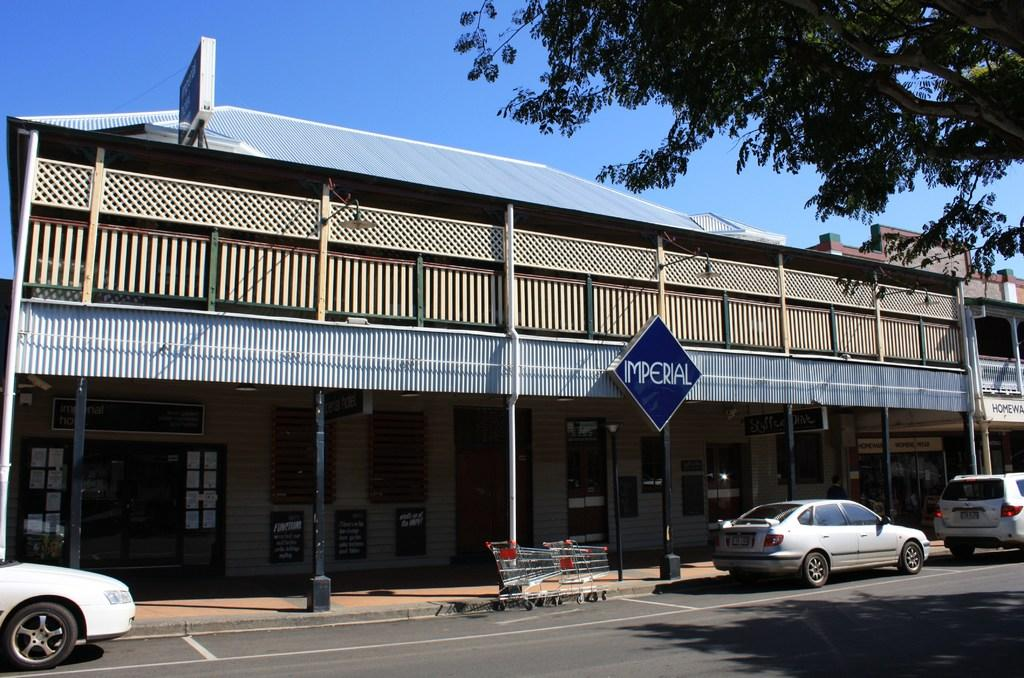What type of vehicles can be seen on the road in the image? The vehicles on the road in the image are trolleys. What is visible in the background of the image? There is a building in the background of the image. Are there any natural elements present in the image? Yes, there is a tree in the image. Can you see a crown on top of the building in the image? There is no crown visible on top of the building in the image. 